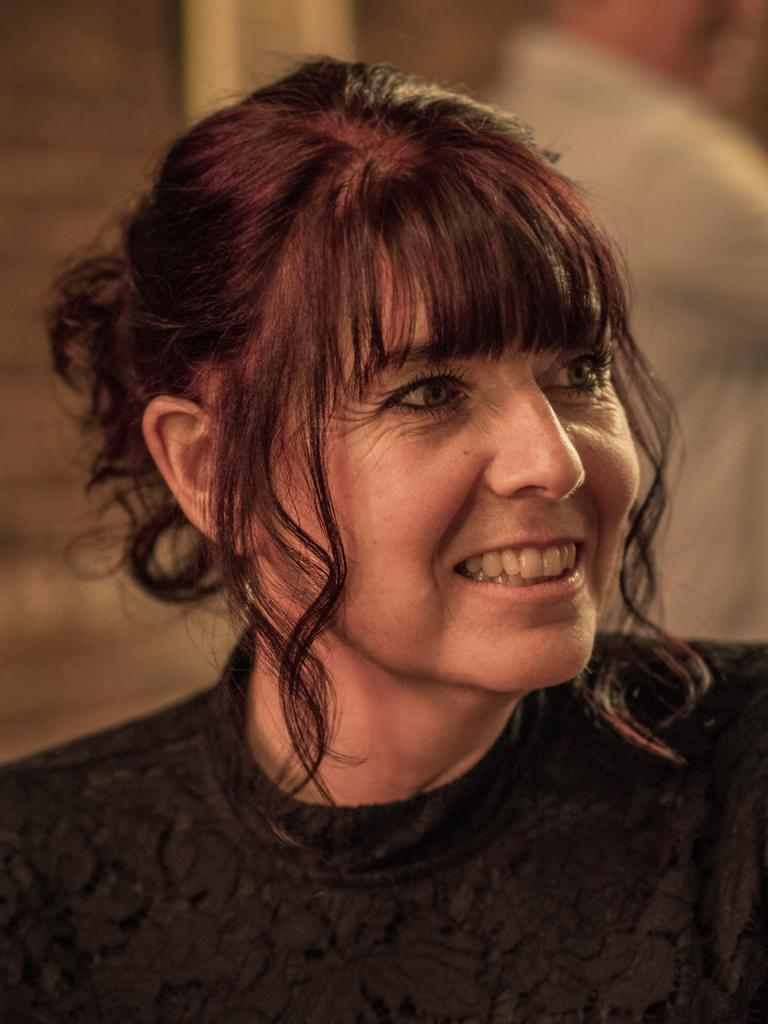Who is present in the image? There is a woman in the image. What is the woman's facial expression? The woman is smiling. Can you describe the background of the image? The background of the image is blurry. How many dolls are sitting on the hen in the image? There are no dolls or hens present in the image; it features a woman with a blurry background. 